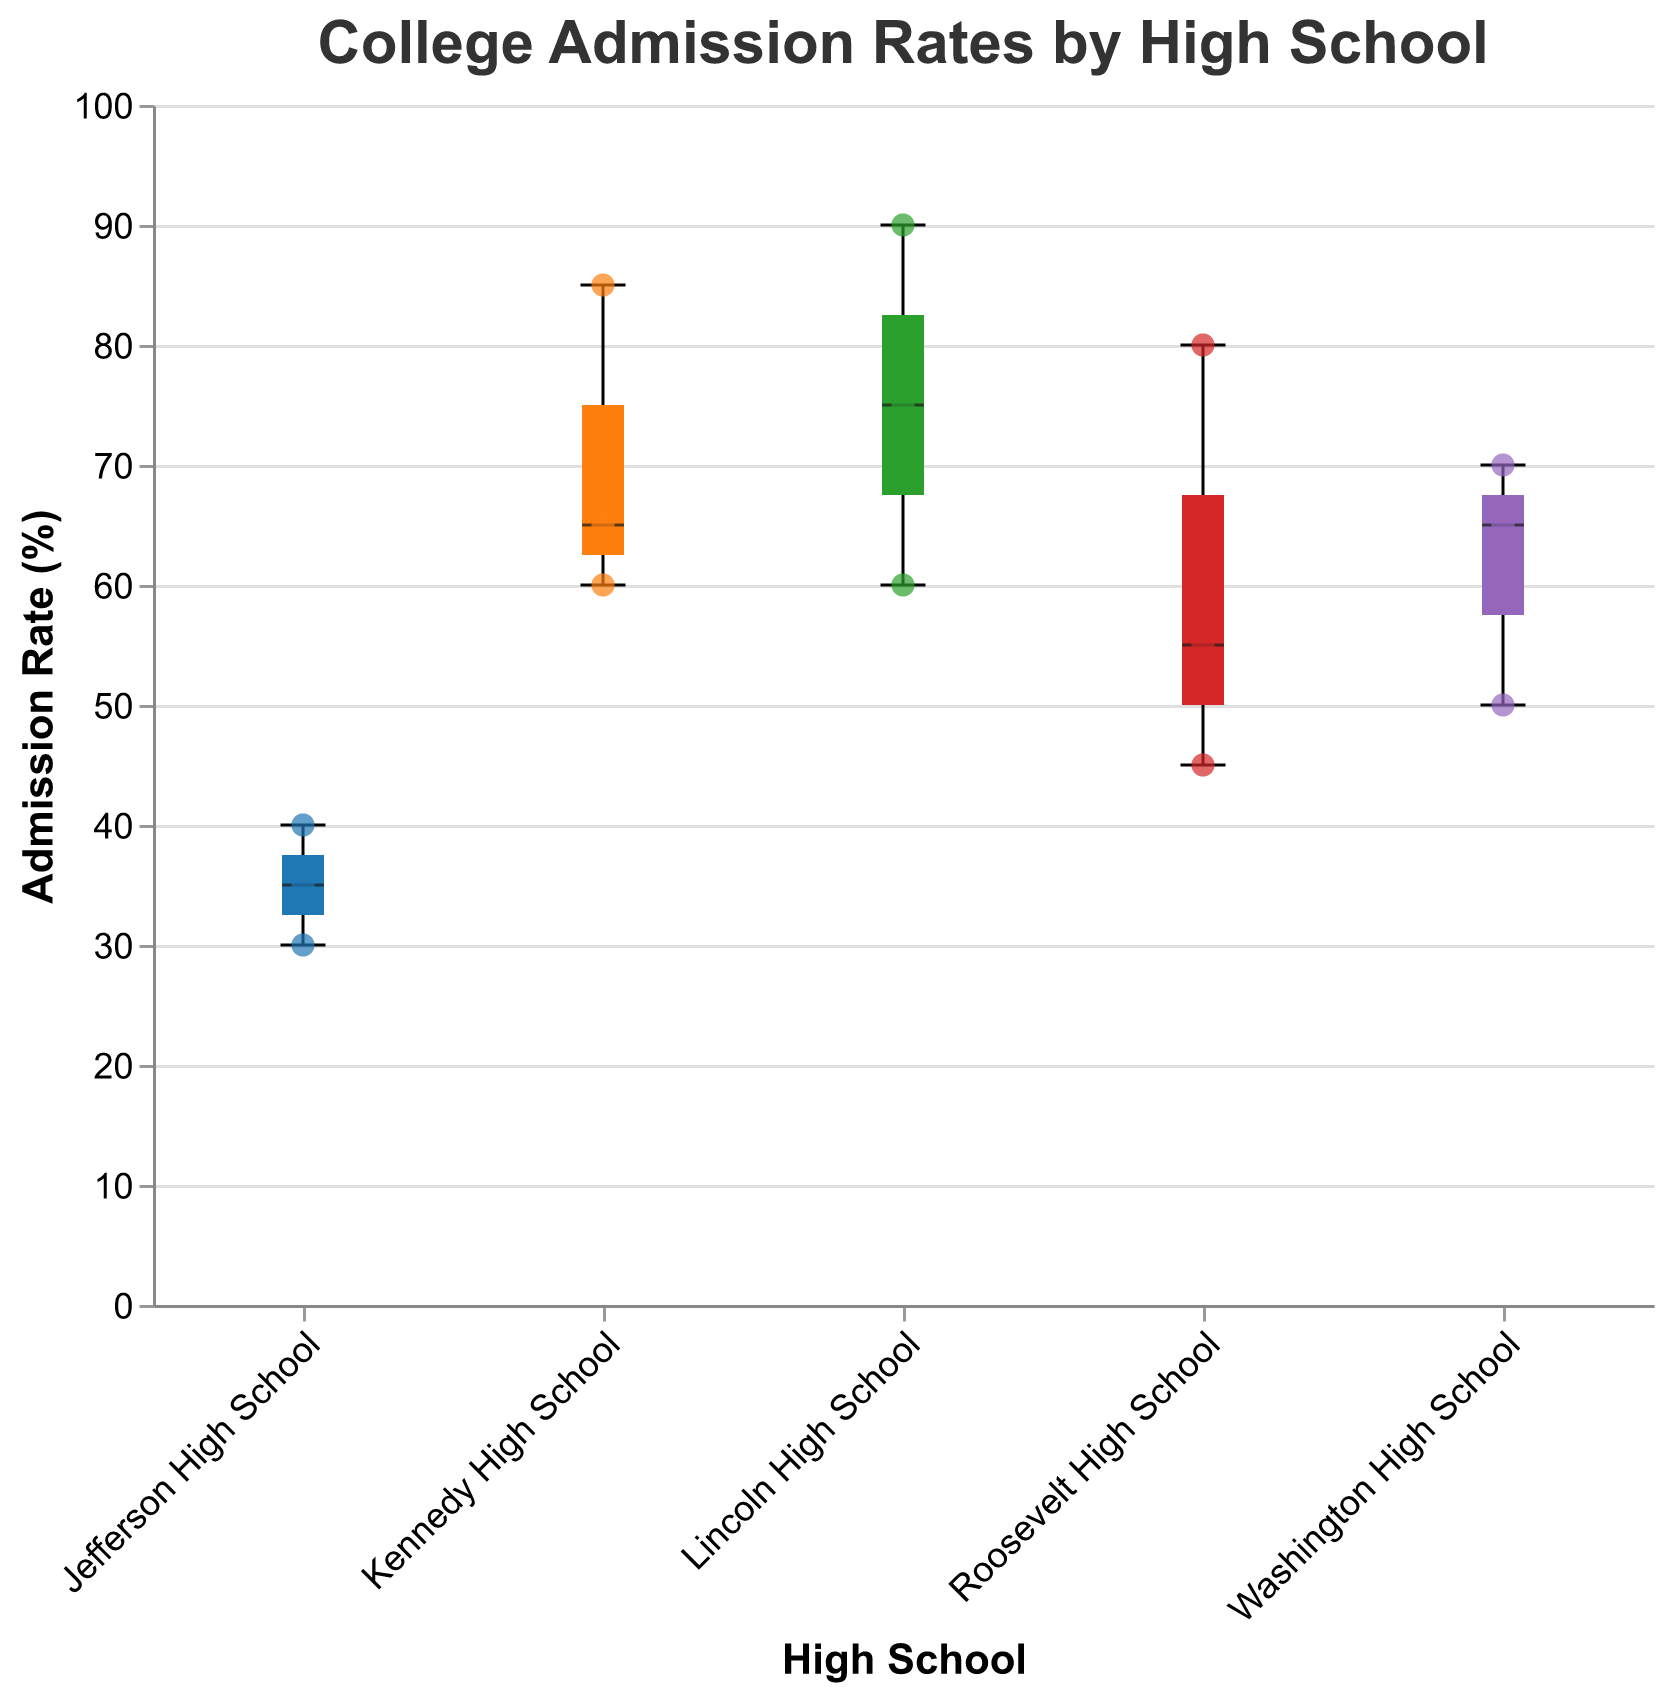What is the title of the figure? The title is displayed at the top of the figure. It reads "College Admission Rates by High School".
Answer: College Admission Rates by High School What range of admission rates do Jefferson High School students have? Looking at the box plot for Jefferson High School on the x-axis, the admission rates range from the minimum value of 30% to the maximum value of 40%.
Answer: 30% to 40% Which high school has the highest median admission rate? In the box plots, the median is indicated by the horizontal line inside the box. The highest median line appears in Lincoln High School.
Answer: Lincoln High School Which high school has the widest range of admission rates? The range is the difference between the minimum and maximum values of the box plot. Roosevelt High School has the widest range, from 45% to 80%.
Answer: Roosevelt High School What is the admission rate of the applicant with ID 010 from Jefferson High School? Referencing the scatter points, the tooltip for Applicant ID 010 indicates an admission rate of 30%.
Answer: 30% How many high schools are represented in the figure? The different colors of the boxes and scatter points represent different high schools. There are five (Lincoln, Washington, Roosevelt, Jefferson, Kennedy) distinct high schools on the x-axis.
Answer: Five Which applicant from Lincoln High School has the highest admission rate? Check the scatter points under Lincoln High School and refer to the tooltips. Applicant ID 003 has the highest admission rate of 90%.
Answer: Applicant ID 003 Which high school has the smallest interquartile range (IQR) for admission rates? The IQR is the range of the middle 50% of data points. Kennedy High School has the smallest IQR, appearing as the narrowest box in the box plot.
Answer: Kennedy High School Compare the highest admission rates recorded for Roosevelt and Washington High Schools. The highest points in the box plot and scatter points show the maximum values. Roosevelt's highest admission rate is 80%, and Washington's is 70%.
Answer: Roosevelt: 80%, Washington: 70% 